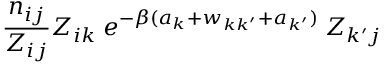Convert formula to latex. <formula><loc_0><loc_0><loc_500><loc_500>\frac { n _ { i j } } { Z _ { i j } } Z _ { i k } \, e ^ { - \beta ( a _ { k } + w _ { k k ^ { \prime } } + a _ { k ^ { \prime } } ) } \, Z _ { k ^ { \prime } j }</formula> 